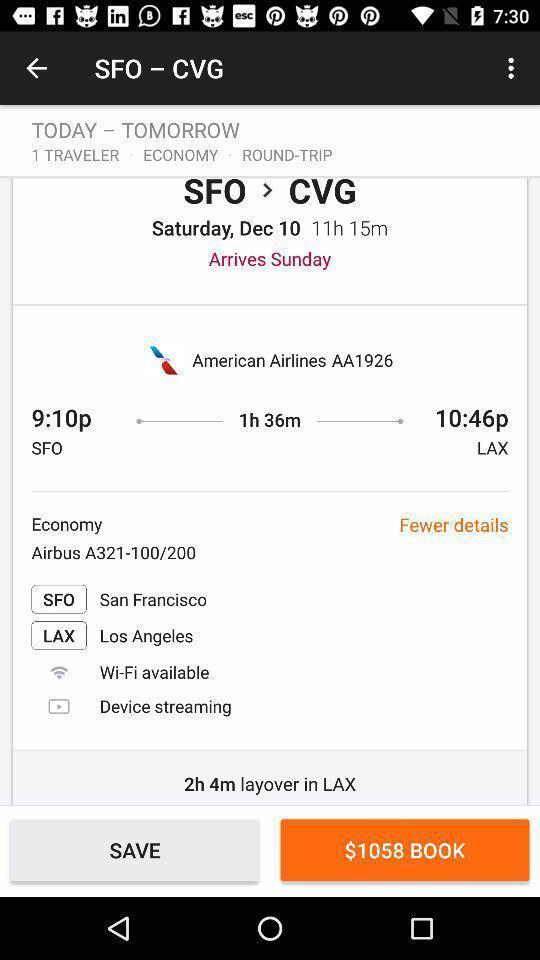Give me a narrative description of this picture. Page displaying travelling details for input locations. 